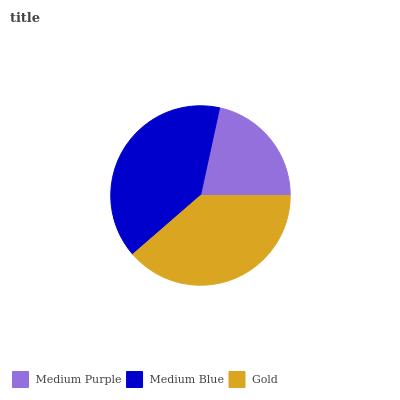Is Medium Purple the minimum?
Answer yes or no. Yes. Is Medium Blue the maximum?
Answer yes or no. Yes. Is Gold the minimum?
Answer yes or no. No. Is Gold the maximum?
Answer yes or no. No. Is Medium Blue greater than Gold?
Answer yes or no. Yes. Is Gold less than Medium Blue?
Answer yes or no. Yes. Is Gold greater than Medium Blue?
Answer yes or no. No. Is Medium Blue less than Gold?
Answer yes or no. No. Is Gold the high median?
Answer yes or no. Yes. Is Gold the low median?
Answer yes or no. Yes. Is Medium Blue the high median?
Answer yes or no. No. Is Medium Purple the low median?
Answer yes or no. No. 